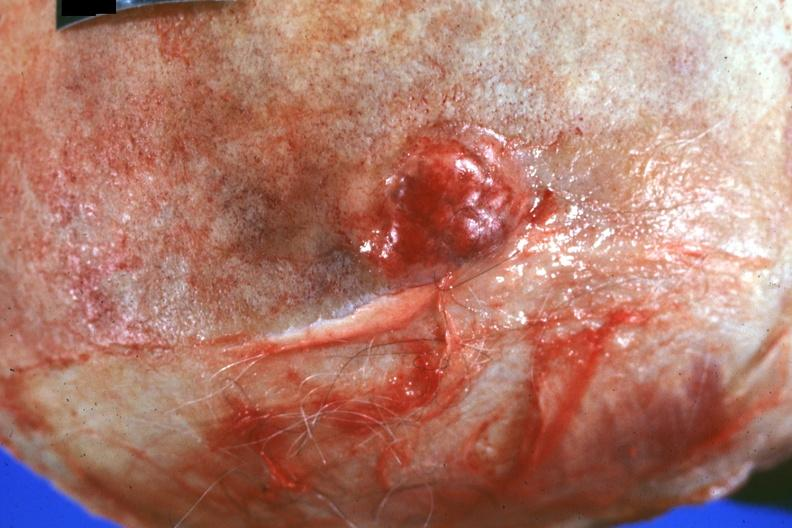does intrauterine contraceptive device show close-up of obvious lesion primary in prostate?
Answer the question using a single word or phrase. No 